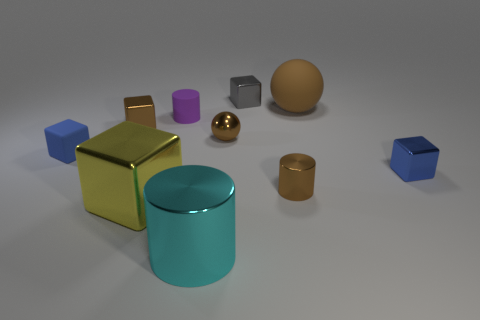Which object stands out the most, and why might that be? The large gold cube stands out prominently due to its size and shininess. Its reflective surface and the contrast with the surrounding objects draw the viewer's attention. Does the lighting reveal anything about the texture of the objects? Yes, it does. The difference in lighting on the objects indicates a variety of textures. The sphere and the large cube, for example, have smooth and reflective surfaces, as indicated by the clear bright spots and defined reflections, while the matte ball has a diffused reflection, suggesting a non-glossy texture. 